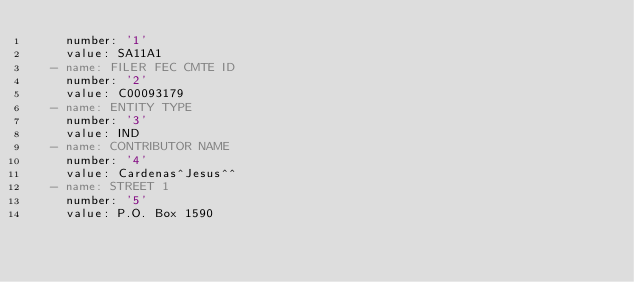Convert code to text. <code><loc_0><loc_0><loc_500><loc_500><_YAML_>    number: '1'
    value: SA11A1
  - name: FILER FEC CMTE ID
    number: '2'
    value: C00093179
  - name: ENTITY TYPE
    number: '3'
    value: IND
  - name: CONTRIBUTOR NAME
    number: '4'
    value: Cardenas^Jesus^^
  - name: STREET 1
    number: '5'
    value: P.O. Box 1590</code> 